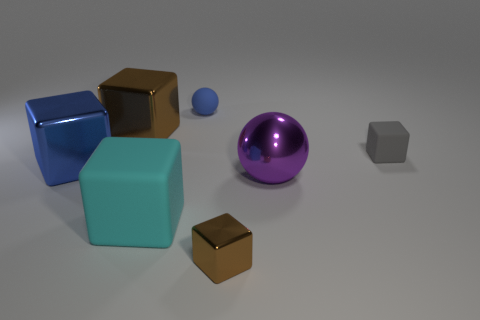Subtract 2 blocks. How many blocks are left? 3 Subtract all cyan cubes. How many cubes are left? 4 Subtract all gray matte cubes. How many cubes are left? 4 Subtract all purple cubes. Subtract all purple balls. How many cubes are left? 5 Add 2 tiny gray things. How many objects exist? 9 Subtract all balls. How many objects are left? 5 Add 5 tiny brown things. How many tiny brown things exist? 6 Subtract 0 cyan cylinders. How many objects are left? 7 Subtract all big metal objects. Subtract all large blue things. How many objects are left? 3 Add 4 tiny rubber things. How many tiny rubber things are left? 6 